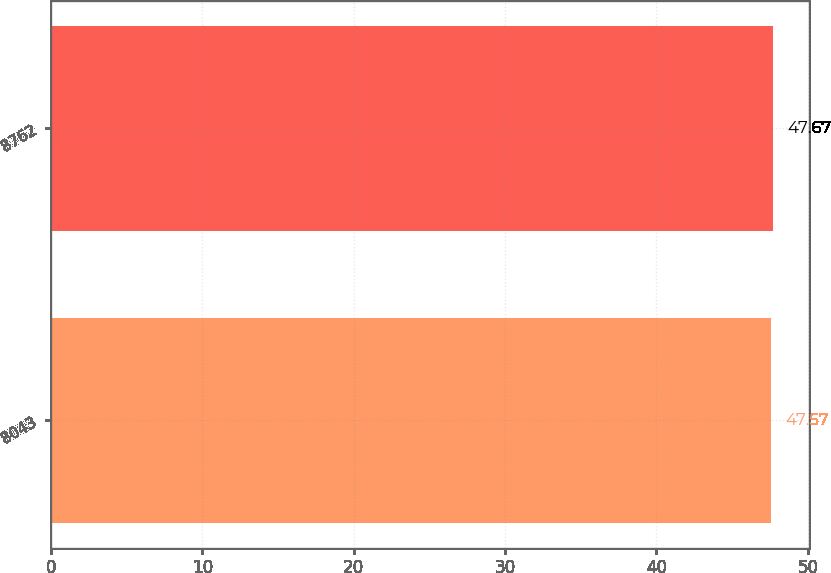<chart> <loc_0><loc_0><loc_500><loc_500><bar_chart><fcel>8043<fcel>8762<nl><fcel>47.57<fcel>47.67<nl></chart> 